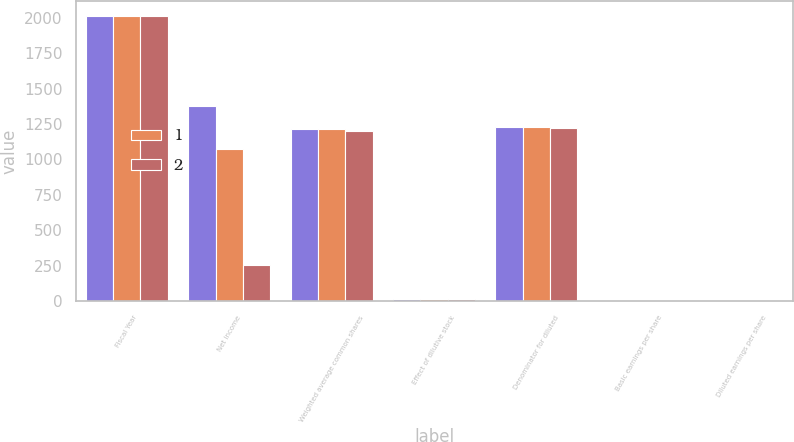<chart> <loc_0><loc_0><loc_500><loc_500><stacked_bar_chart><ecel><fcel>Fiscal Year<fcel>Net income<fcel>Weighted average common shares<fcel>Effect of dilutive stock<fcel>Denominator for diluted<fcel>Basic earnings per share<fcel>Diluted earnings per share<nl><fcel>nan<fcel>2015<fcel>1377<fcel>1214<fcel>12<fcel>1226<fcel>1.13<fcel>1.12<nl><fcel>1<fcel>2014<fcel>1072<fcel>1215<fcel>16<fcel>1231<fcel>0.88<fcel>0.87<nl><fcel>2<fcel>2013<fcel>256<fcel>1202<fcel>17<fcel>1219<fcel>0.21<fcel>0.21<nl></chart> 